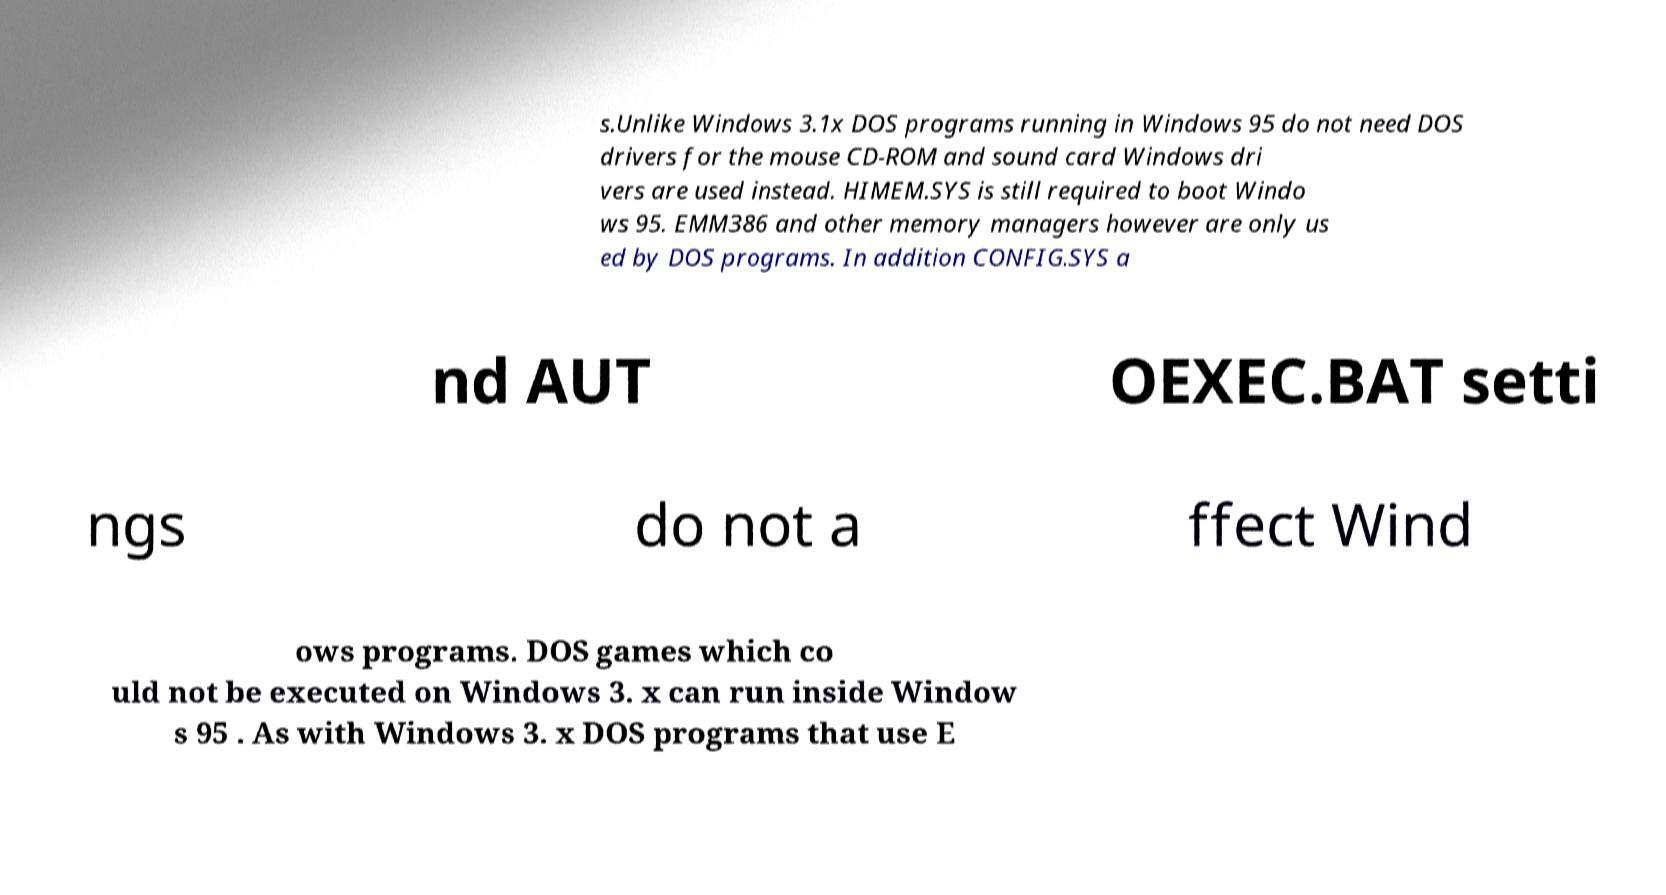Can you read and provide the text displayed in the image?This photo seems to have some interesting text. Can you extract and type it out for me? s.Unlike Windows 3.1x DOS programs running in Windows 95 do not need DOS drivers for the mouse CD-ROM and sound card Windows dri vers are used instead. HIMEM.SYS is still required to boot Windo ws 95. EMM386 and other memory managers however are only us ed by DOS programs. In addition CONFIG.SYS a nd AUT OEXEC.BAT setti ngs do not a ffect Wind ows programs. DOS games which co uld not be executed on Windows 3. x can run inside Window s 95 . As with Windows 3. x DOS programs that use E 